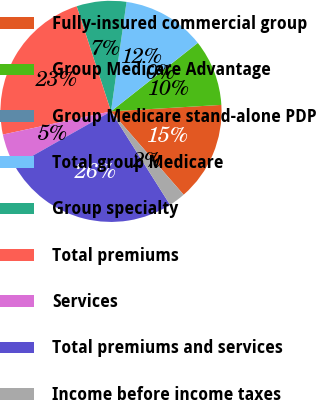<chart> <loc_0><loc_0><loc_500><loc_500><pie_chart><fcel>Fully-insured commercial group<fcel>Group Medicare Advantage<fcel>Group Medicare stand-alone PDP<fcel>Total group Medicare<fcel>Group specialty<fcel>Total premiums<fcel>Services<fcel>Total premiums and services<fcel>Income before income taxes<nl><fcel>14.52%<fcel>9.69%<fcel>0.02%<fcel>12.11%<fcel>7.27%<fcel>23.34%<fcel>4.85%<fcel>25.76%<fcel>2.44%<nl></chart> 